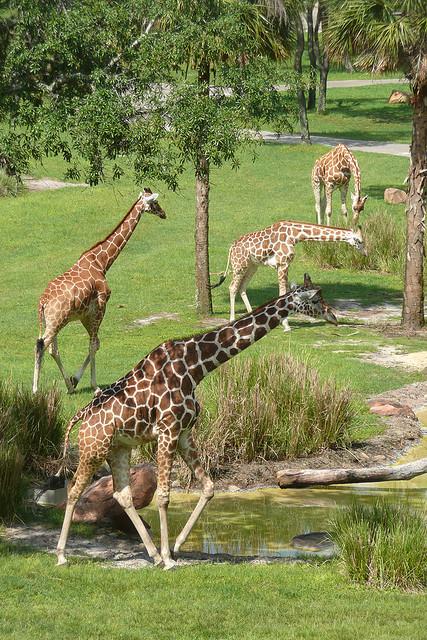Are the animals free?
Answer briefly. No. Would Liam Neeson be in danger from these creatures?
Quick response, please. No. How many giraffes can you see?
Concise answer only. 4. How many animal is in this picture?
Short answer required. 4. Are these adult giraffes?
Answer briefly. Yes. 